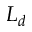<formula> <loc_0><loc_0><loc_500><loc_500>L _ { d }</formula> 